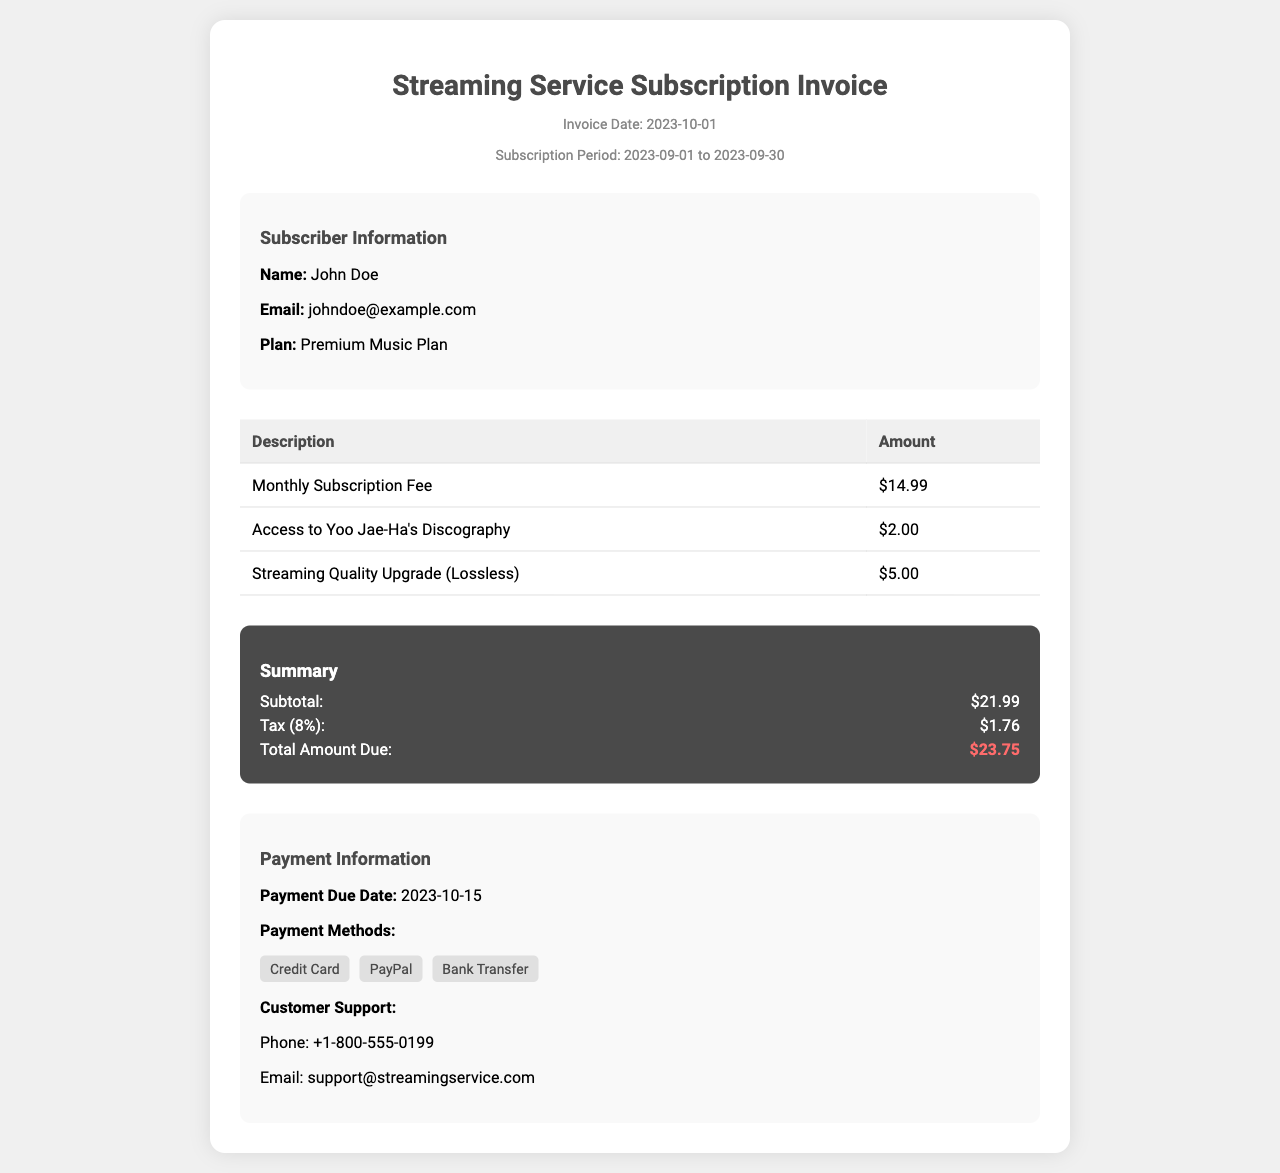What is the invoice date? The invoice date can be found in the document header, which specifies "Invoice Date: 2023-10-01".
Answer: 2023-10-01 What is the total amount due? The total amount due is listed in the summary section as "Total Amount Due: $23.75".
Answer: $23.75 Who is the subscriber? The subscriber's name is indicated in the subscriber information section as "John Doe".
Answer: John Doe What is the subscription plan? The subscription plan is mentioned in the subscriber information as "Premium Music Plan".
Answer: Premium Music Plan How much is the access to Yoo Jae-Ha's discography? The invoice lists "Access to Yoo Jae-Ha's Discography" for $2.00.
Answer: $2.00 What is the payment due date? The payment due date is provided in the payment information section as "Payment Due Date: 2023-10-15".
Answer: 2023-10-15 What percentage tax is applied? The document states "Tax (8%)" indicating the percentage applied.
Answer: 8% How many payment methods are listed? The document lists three payment methods in the payment information section.
Answer: Three What is the subtotal amount? The subtotal amount is specified in the summary section as "$21.99".
Answer: $21.99 